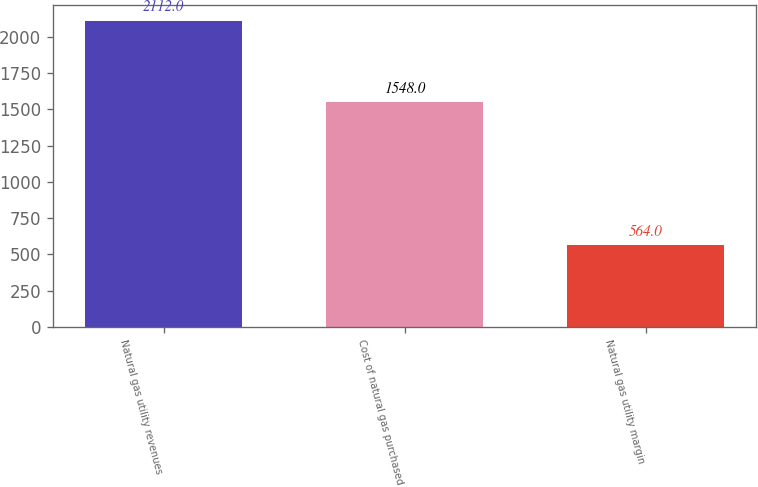Convert chart. <chart><loc_0><loc_0><loc_500><loc_500><bar_chart><fcel>Natural gas utility revenues<fcel>Cost of natural gas purchased<fcel>Natural gas utility margin<nl><fcel>2112<fcel>1548<fcel>564<nl></chart> 